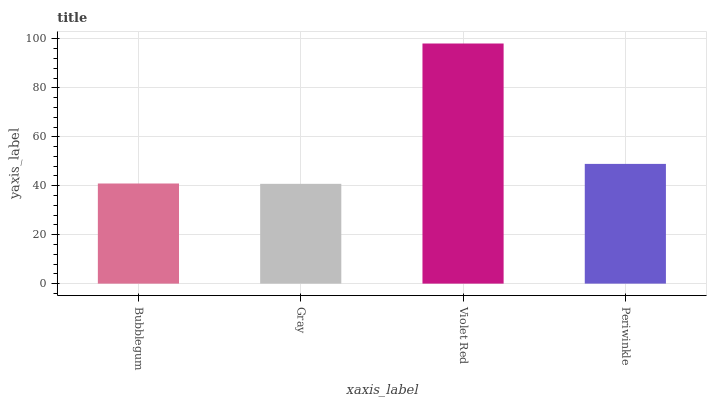Is Violet Red the minimum?
Answer yes or no. No. Is Gray the maximum?
Answer yes or no. No. Is Violet Red greater than Gray?
Answer yes or no. Yes. Is Gray less than Violet Red?
Answer yes or no. Yes. Is Gray greater than Violet Red?
Answer yes or no. No. Is Violet Red less than Gray?
Answer yes or no. No. Is Periwinkle the high median?
Answer yes or no. Yes. Is Bubblegum the low median?
Answer yes or no. Yes. Is Violet Red the high median?
Answer yes or no. No. Is Periwinkle the low median?
Answer yes or no. No. 